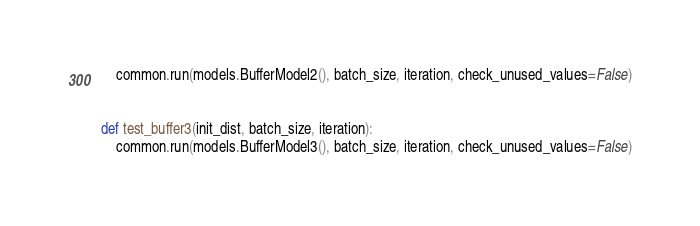Convert code to text. <code><loc_0><loc_0><loc_500><loc_500><_Python_>    common.run(models.BufferModel2(), batch_size, iteration, check_unused_values=False)


def test_buffer3(init_dist, batch_size, iteration):
    common.run(models.BufferModel3(), batch_size, iteration, check_unused_values=False)

</code> 